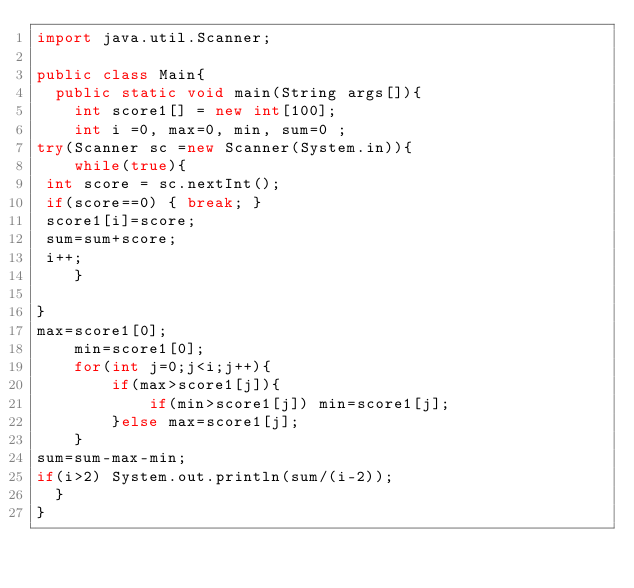<code> <loc_0><loc_0><loc_500><loc_500><_Java_>import java.util.Scanner;

public class Main{
  public static void main(String args[]){
    int score1[] = new int[100];
    int i =0, max=0, min, sum=0 ;
try(Scanner sc =new Scanner(System.in)){
    while(true){
 int score = sc.nextInt();
 if(score==0) { break; }
 score1[i]=score;
 sum=sum+score;
 i++;
    }
   
}
max=score1[0];
    min=score1[0];
    for(int j=0;j<i;j++){
        if(max>score1[j]){
            if(min>score1[j]) min=score1[j];       
        }else max=score1[j];
    }
sum=sum-max-min;
if(i>2) System.out.println(sum/(i-2));
  }
}



        

</code> 